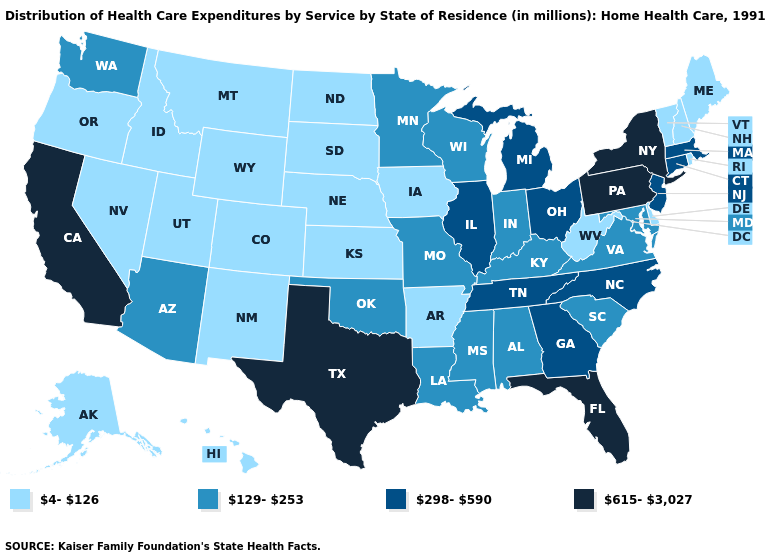Among the states that border Oklahoma , does Colorado have the lowest value?
Quick response, please. Yes. Name the states that have a value in the range 298-590?
Be succinct. Connecticut, Georgia, Illinois, Massachusetts, Michigan, New Jersey, North Carolina, Ohio, Tennessee. What is the value of Michigan?
Keep it brief. 298-590. Among the states that border Kentucky , does West Virginia have the lowest value?
Concise answer only. Yes. What is the highest value in the MidWest ?
Give a very brief answer. 298-590. What is the lowest value in the USA?
Answer briefly. 4-126. Does Maine have the lowest value in the USA?
Give a very brief answer. Yes. Does Texas have the highest value in the USA?
Quick response, please. Yes. Name the states that have a value in the range 4-126?
Concise answer only. Alaska, Arkansas, Colorado, Delaware, Hawaii, Idaho, Iowa, Kansas, Maine, Montana, Nebraska, Nevada, New Hampshire, New Mexico, North Dakota, Oregon, Rhode Island, South Dakota, Utah, Vermont, West Virginia, Wyoming. What is the highest value in the USA?
Be succinct. 615-3,027. Does Iowa have the lowest value in the USA?
Quick response, please. Yes. Name the states that have a value in the range 615-3,027?
Concise answer only. California, Florida, New York, Pennsylvania, Texas. Name the states that have a value in the range 298-590?
Answer briefly. Connecticut, Georgia, Illinois, Massachusetts, Michigan, New Jersey, North Carolina, Ohio, Tennessee. Name the states that have a value in the range 615-3,027?
Be succinct. California, Florida, New York, Pennsylvania, Texas. What is the value of New Jersey?
Keep it brief. 298-590. 